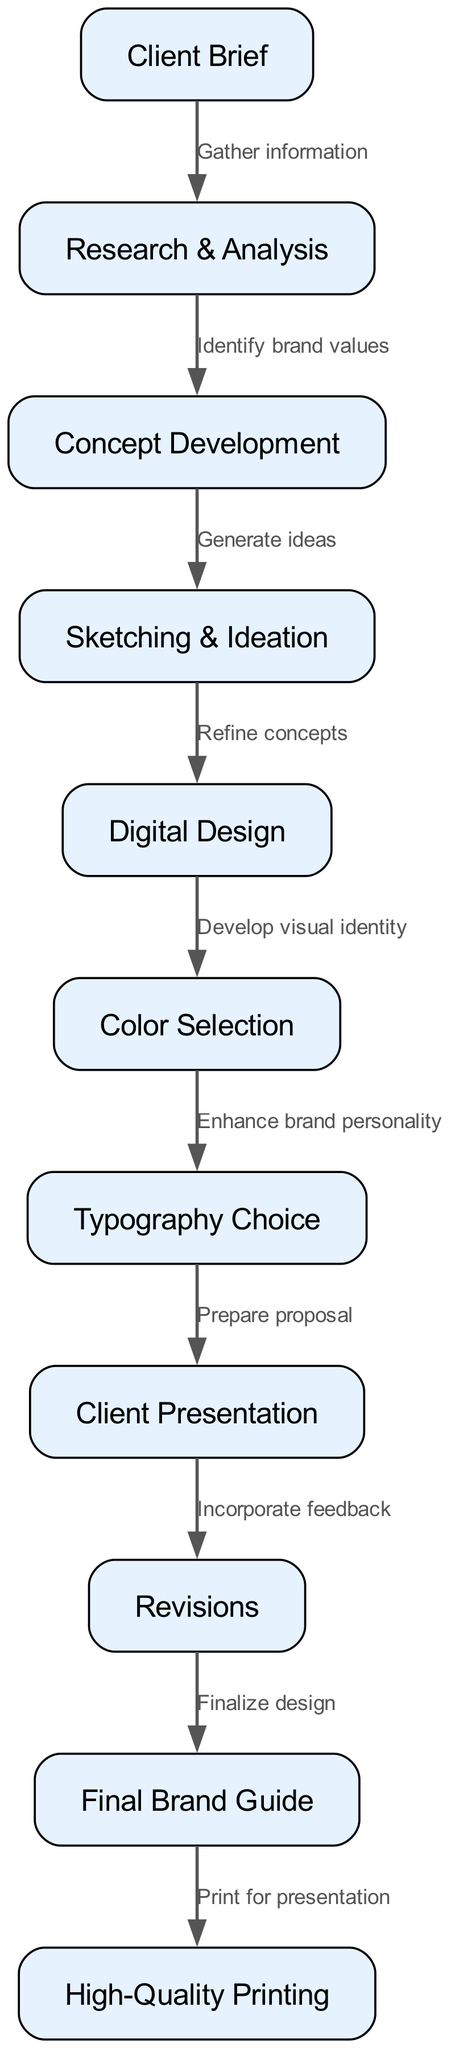What is the first step in the design process? The first node in the diagram is "Client Brief," indicating that it's the initial step in the design process.
Answer: Client Brief How many total nodes are present in the diagram? Counting the individual nodes listed in the data, there are a total of eleven nodes that represent different steps in the design process.
Answer: 11 What is the relationship between "Research & Analysis" and "Concept Development"? The edge connecting these two nodes indicates that "Research & Analysis" leads to "Concept Development," specifically stating the reason as "Identify brand values."
Answer: Identify brand values What is the step immediately before "High-Quality Printing"? The node directly preceding "High-Quality Printing" is "Final Brand Guide," which indicates the last step before the printing stage.
Answer: Final Brand Guide What action occurs after "Client Presentation"? The diagram shows that after "Client Presentation," the next action is "Revisions," which involves incorporating any feedback received from the client.
Answer: Revisions Which step develops the visual identity of the brand? The node labeled "Digital Design" is where the visual identity is developed as indicated by the edge leading from this step to "Color Selection."
Answer: Digital Design How many edges are there connecting the nodes in the diagram? By counting all the connections (or edges) that lead from one node to another in the diagram, there are a total of ten edges that represent the flow between these steps.
Answer: 10 Which stage prepares the proposal for the client? The stage that prepares the proposal for the client is "Client Presentation," which is indicated by an edge leading to it from "Typography Choice."
Answer: Client Presentation What is the final output of the design process? The last node in the diagram indicates that the final output of the design process is the "Final Brand Guide," which serves as the comprehensive document for the brand identity.
Answer: Final Brand Guide 